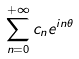Convert formula to latex. <formula><loc_0><loc_0><loc_500><loc_500>\sum _ { n = 0 } ^ { + \infty } c _ { n } e ^ { i n \theta }</formula> 